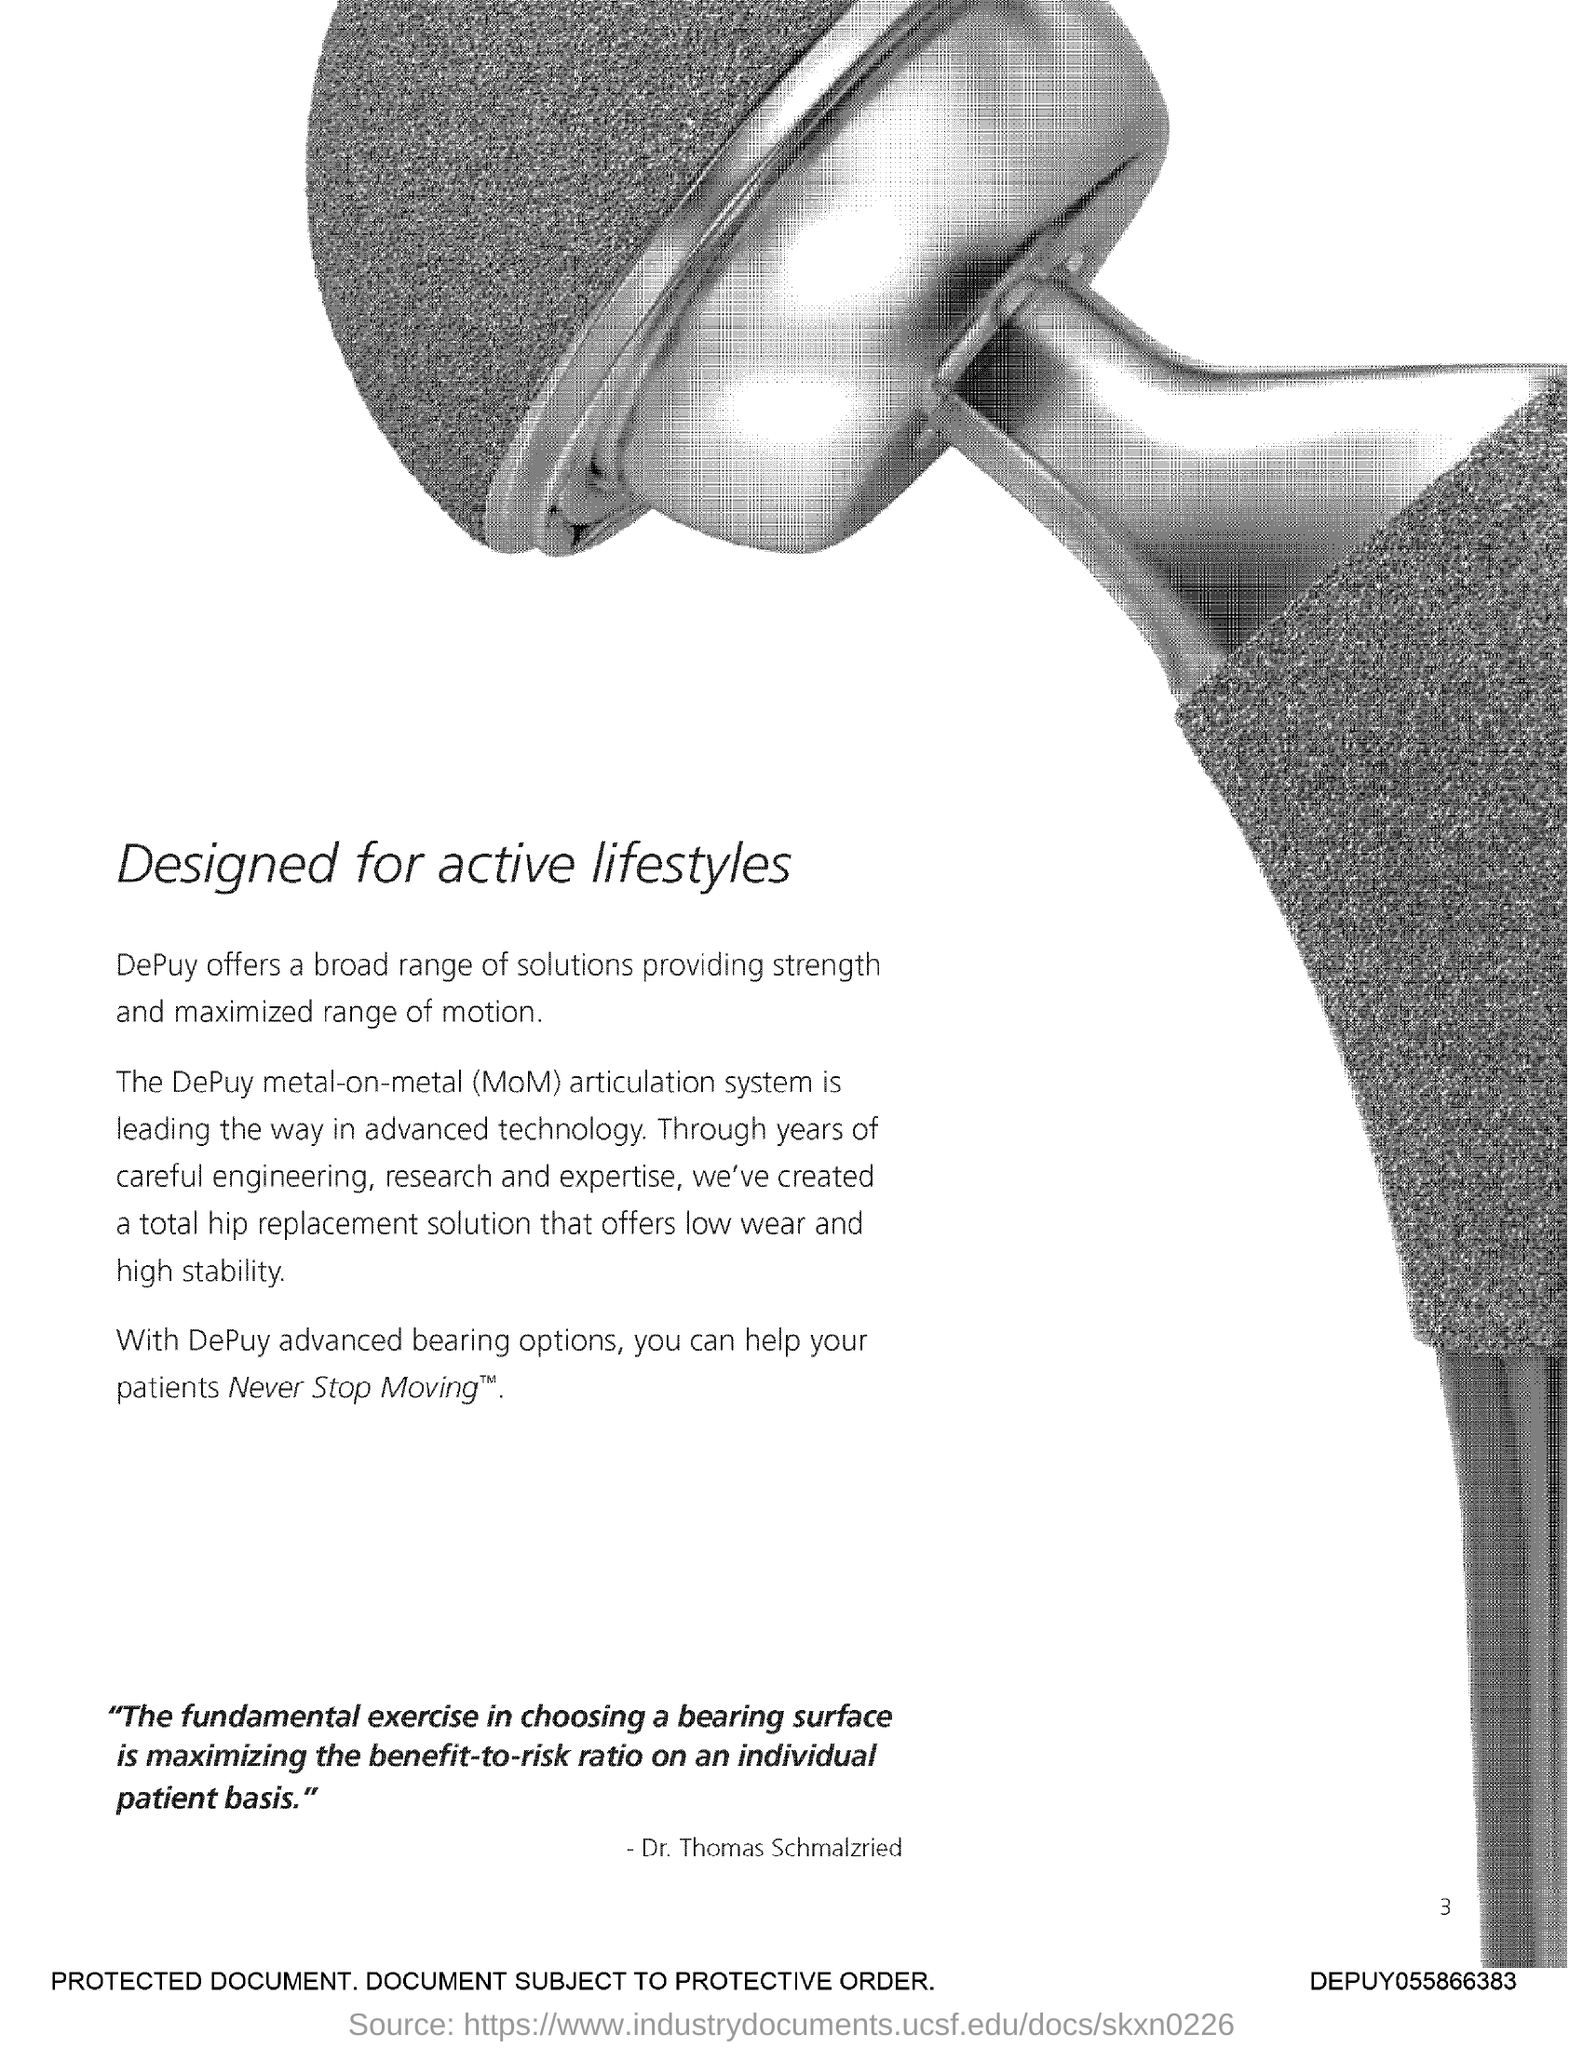What is the Page Number?
Provide a short and direct response. 3. 